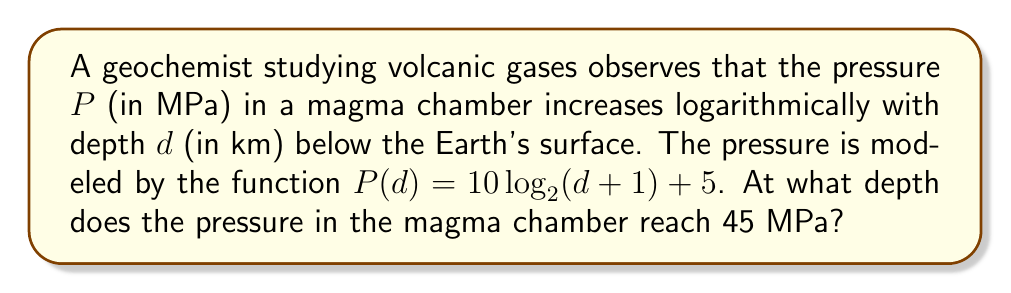Can you solve this math problem? To solve this problem, we need to follow these steps:

1) We are given the pressure function:
   $P(d) = 10 \log_{2}(d + 1) + 5$

2) We want to find $d$ when $P(d) = 45$. So, let's set up the equation:
   $45 = 10 \log_{2}(d + 1) + 5$

3) Subtract 5 from both sides:
   $40 = 10 \log_{2}(d + 1)$

4) Divide both sides by 10:
   $4 = \log_{2}(d + 1)$

5) To solve for $d$, we need to apply the inverse function of $\log_{2}$, which is $2^x$:
   $2^4 = d + 1$

6) Simplify the left side:
   $16 = d + 1$

7) Subtract 1 from both sides to isolate $d$:
   $15 = d$

Therefore, the pressure in the magma chamber reaches 45 MPa at a depth of 15 km below the Earth's surface.
Answer: 15 km 